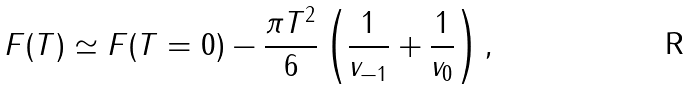<formula> <loc_0><loc_0><loc_500><loc_500>F ( T ) \simeq F ( T = 0 ) - \frac { \pi T ^ { 2 } } { 6 } \left ( \frac { 1 } { v _ { - 1 } } + \frac { 1 } { v _ { 0 } } \right ) ,</formula> 